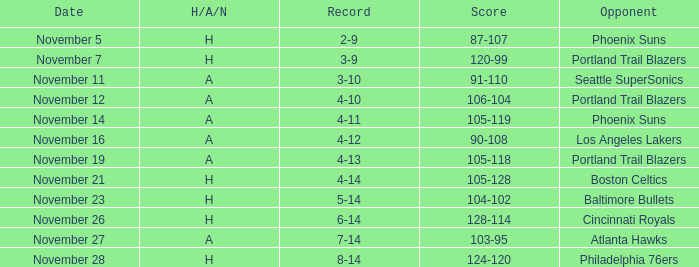What was the Opponent when the Cavaliers had a Record of 3-9? Portland Trail Blazers. 